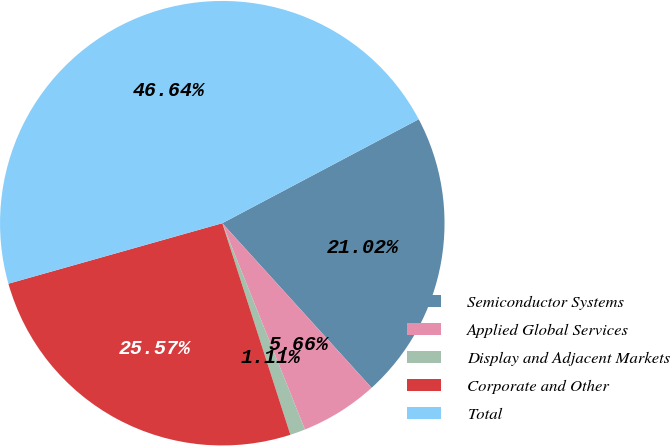Convert chart to OTSL. <chart><loc_0><loc_0><loc_500><loc_500><pie_chart><fcel>Semiconductor Systems<fcel>Applied Global Services<fcel>Display and Adjacent Markets<fcel>Corporate and Other<fcel>Total<nl><fcel>21.02%<fcel>5.66%<fcel>1.11%<fcel>25.57%<fcel>46.64%<nl></chart> 